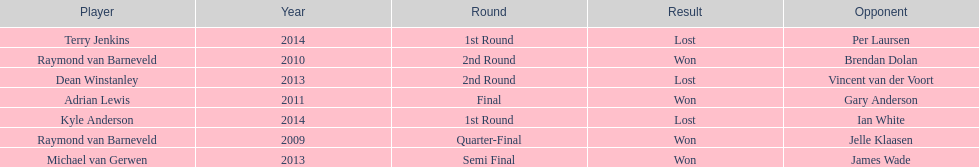Is dean winstanley listed above or below kyle anderson? Above. 